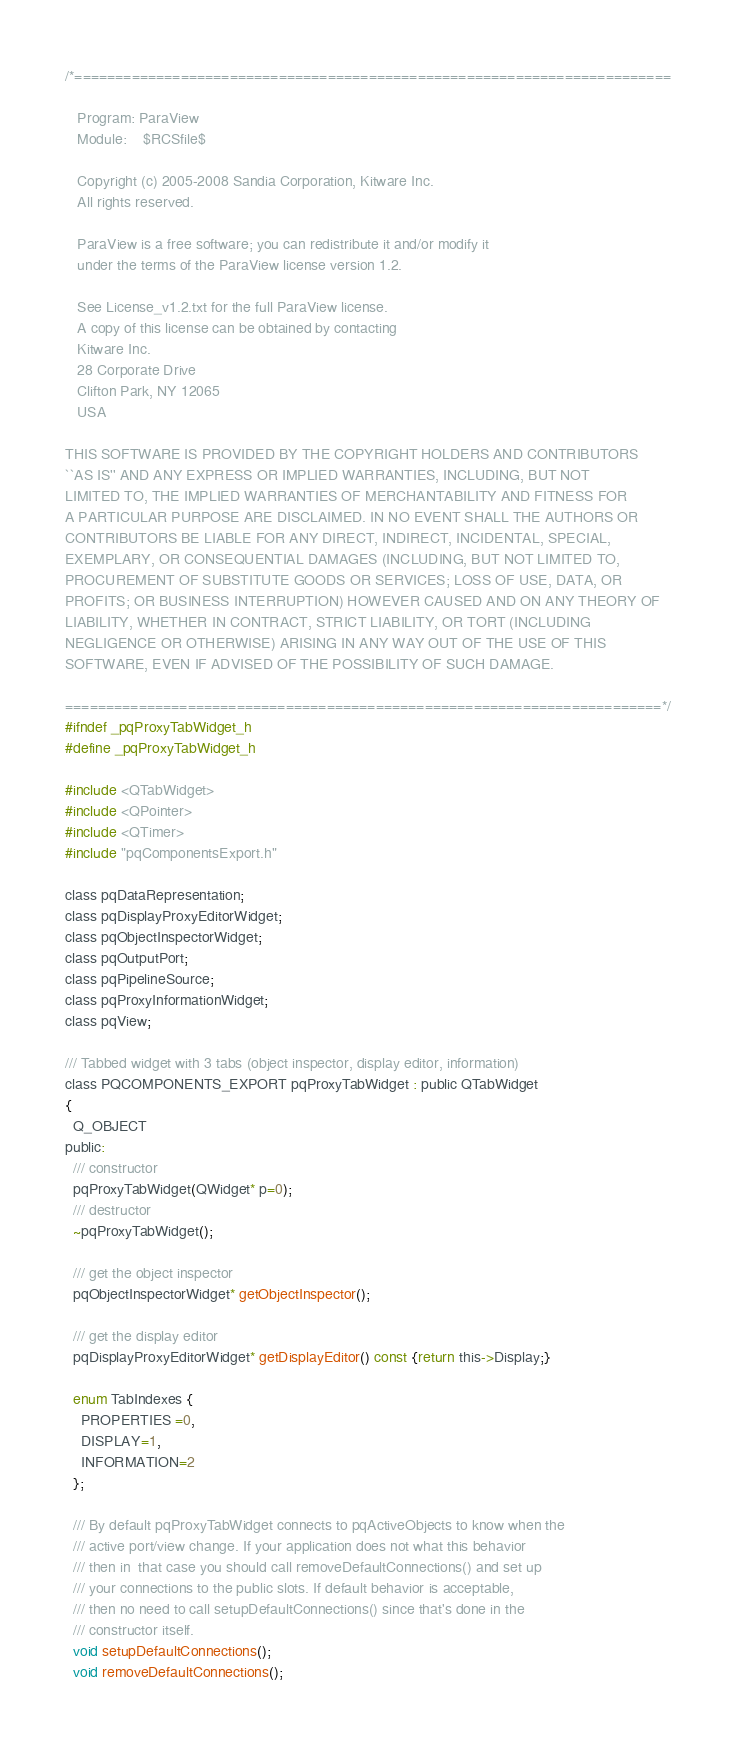Convert code to text. <code><loc_0><loc_0><loc_500><loc_500><_C_>/*=========================================================================

   Program: ParaView
   Module:    $RCSfile$

   Copyright (c) 2005-2008 Sandia Corporation, Kitware Inc.
   All rights reserved.

   ParaView is a free software; you can redistribute it and/or modify it
   under the terms of the ParaView license version 1.2. 

   See License_v1.2.txt for the full ParaView license.
   A copy of this license can be obtained by contacting
   Kitware Inc.
   28 Corporate Drive
   Clifton Park, NY 12065
   USA

THIS SOFTWARE IS PROVIDED BY THE COPYRIGHT HOLDERS AND CONTRIBUTORS
``AS IS'' AND ANY EXPRESS OR IMPLIED WARRANTIES, INCLUDING, BUT NOT
LIMITED TO, THE IMPLIED WARRANTIES OF MERCHANTABILITY AND FITNESS FOR
A PARTICULAR PURPOSE ARE DISCLAIMED. IN NO EVENT SHALL THE AUTHORS OR
CONTRIBUTORS BE LIABLE FOR ANY DIRECT, INDIRECT, INCIDENTAL, SPECIAL,
EXEMPLARY, OR CONSEQUENTIAL DAMAGES (INCLUDING, BUT NOT LIMITED TO,
PROCUREMENT OF SUBSTITUTE GOODS OR SERVICES; LOSS OF USE, DATA, OR
PROFITS; OR BUSINESS INTERRUPTION) HOWEVER CAUSED AND ON ANY THEORY OF
LIABILITY, WHETHER IN CONTRACT, STRICT LIABILITY, OR TORT (INCLUDING
NEGLIGENCE OR OTHERWISE) ARISING IN ANY WAY OUT OF THE USE OF THIS
SOFTWARE, EVEN IF ADVISED OF THE POSSIBILITY OF SUCH DAMAGE.

=========================================================================*/
#ifndef _pqProxyTabWidget_h
#define _pqProxyTabWidget_h

#include <QTabWidget>
#include <QPointer>
#include <QTimer>
#include "pqComponentsExport.h"

class pqDataRepresentation;
class pqDisplayProxyEditorWidget;
class pqObjectInspectorWidget;
class pqOutputPort;
class pqPipelineSource;
class pqProxyInformationWidget;
class pqView;

/// Tabbed widget with 3 tabs (object inspector, display editor, information)
class PQCOMPONENTS_EXPORT pqProxyTabWidget : public QTabWidget
{
  Q_OBJECT
public:
  /// constructor
  pqProxyTabWidget(QWidget* p=0);
  /// destructor
  ~pqProxyTabWidget();

  /// get the object inspector
  pqObjectInspectorWidget* getObjectInspector();

  /// get the display editor
  pqDisplayProxyEditorWidget* getDisplayEditor() const {return this->Display;}
  
  enum TabIndexes {
    PROPERTIES =0,
    DISPLAY=1,
    INFORMATION=2
  };

  /// By default pqProxyTabWidget connects to pqActiveObjects to know when the
  /// active port/view change. If your application does not what this behavior
  /// then in  that case you should call removeDefaultConnections() and set up
  /// your connections to the public slots. If default behavior is acceptable,
  /// then no need to call setupDefaultConnections() since that's done in the
  /// constructor itself.
  void setupDefaultConnections();
  void removeDefaultConnections();
</code> 